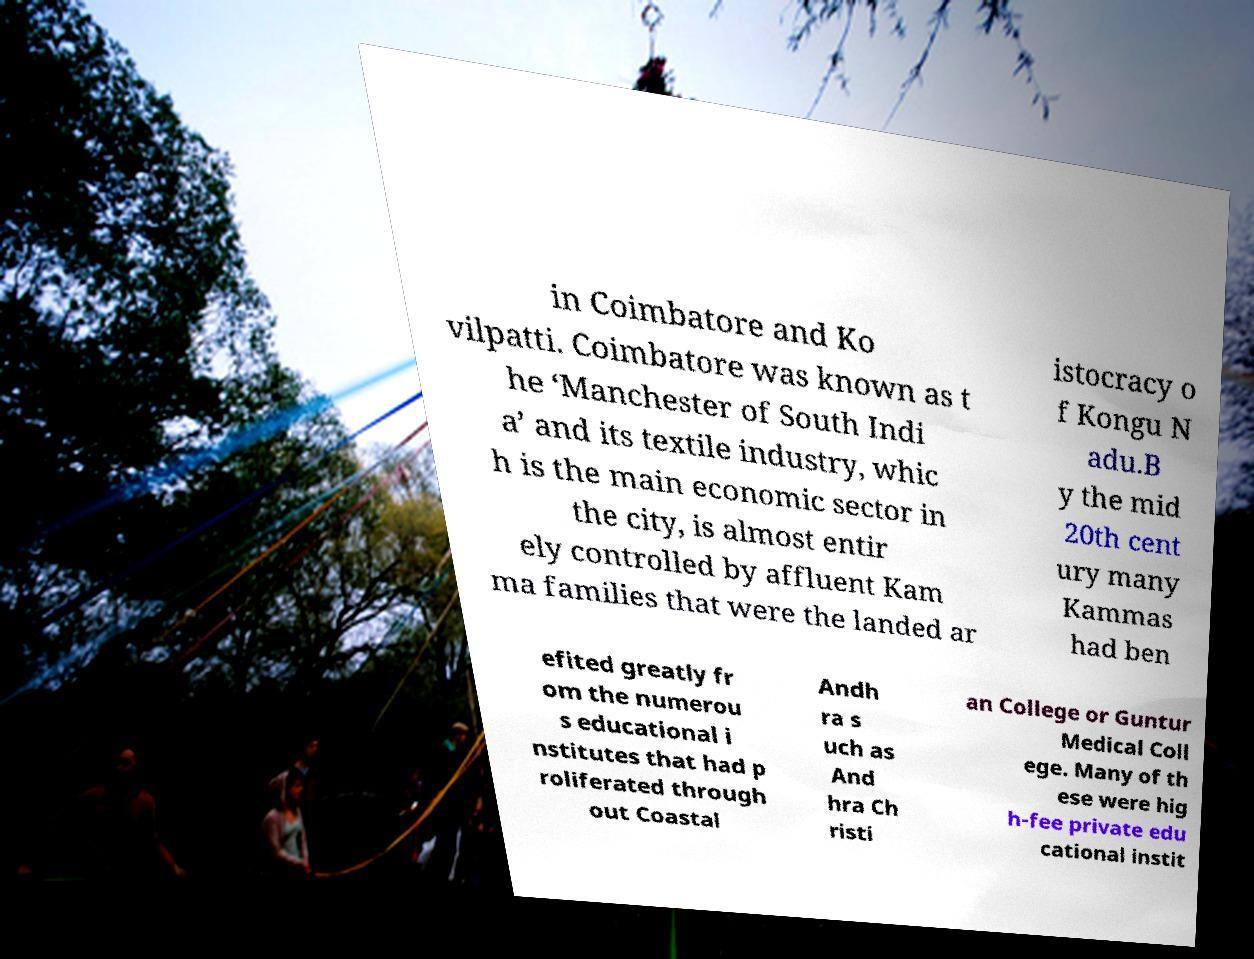For documentation purposes, I need the text within this image transcribed. Could you provide that? in Coimbatore and Ko vilpatti. Coimbatore was known as t he ‘Manchester of South Indi a’ and its textile industry, whic h is the main economic sector in the city, is almost entir ely controlled by affluent Kam ma families that were the landed ar istocracy o f Kongu N adu.B y the mid 20th cent ury many Kammas had ben efited greatly fr om the numerou s educational i nstitutes that had p roliferated through out Coastal Andh ra s uch as And hra Ch risti an College or Guntur Medical Coll ege. Many of th ese were hig h-fee private edu cational instit 